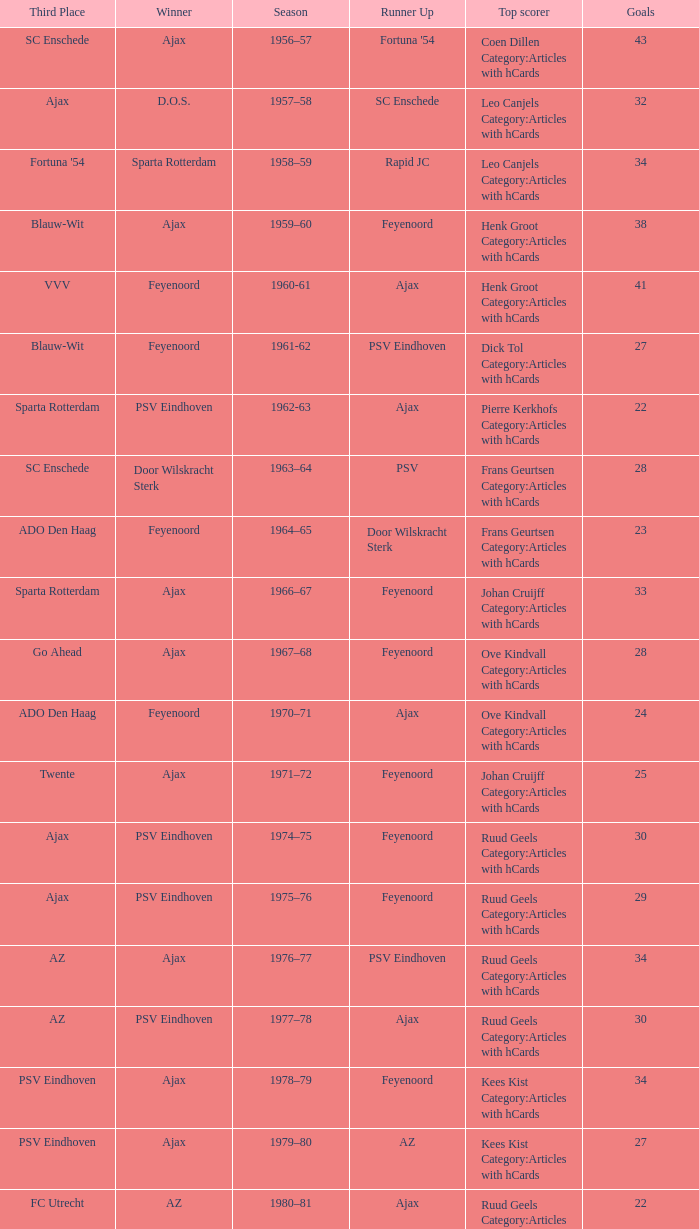When twente came in third place and ajax was the winner what are the seasons? 1971–72, 1989-90. 